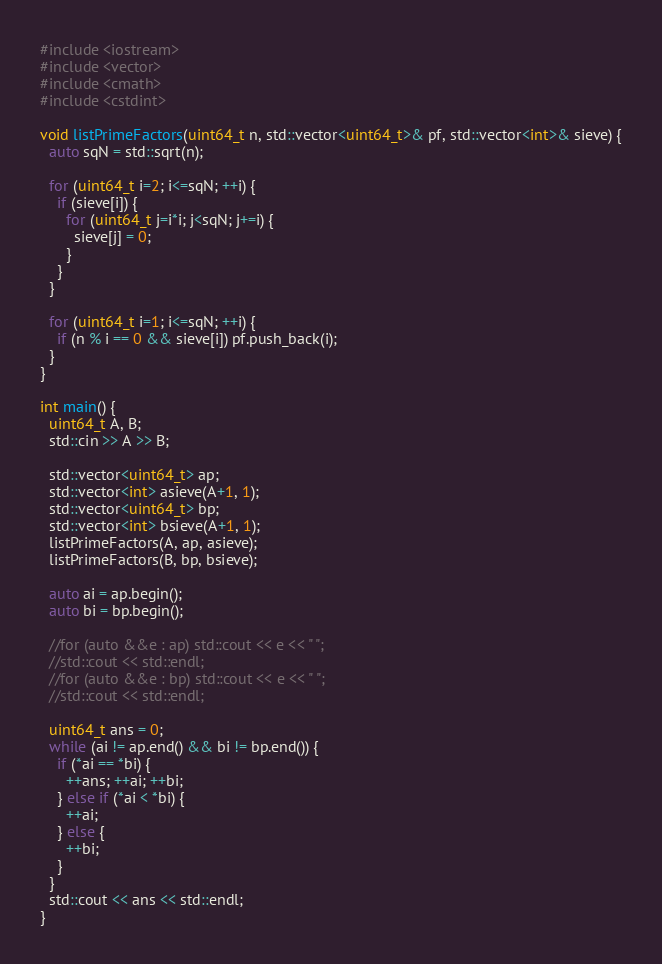Convert code to text. <code><loc_0><loc_0><loc_500><loc_500><_C++_>#include <iostream>
#include <vector>
#include <cmath>
#include <cstdint>

void listPrimeFactors(uint64_t n, std::vector<uint64_t>& pf, std::vector<int>& sieve) {
  auto sqN = std::sqrt(n);
  
  for (uint64_t i=2; i<=sqN; ++i) {
    if (sieve[i]) {
      for (uint64_t j=i*i; j<sqN; j+=i) {
        sieve[j] = 0;
      }
    }
  }
  
  for (uint64_t i=1; i<=sqN; ++i) {
    if (n % i == 0 && sieve[i]) pf.push_back(i);
  }
}

int main() {
  uint64_t A, B;
  std::cin >> A >> B;
  
  std::vector<uint64_t> ap;
  std::vector<int> asieve(A+1, 1);
  std::vector<uint64_t> bp;
  std::vector<int> bsieve(A+1, 1);
  listPrimeFactors(A, ap, asieve);
  listPrimeFactors(B, bp, bsieve);
  
  auto ai = ap.begin();
  auto bi = bp.begin();
  
  //for (auto &&e : ap) std::cout << e << " ";
  //std::cout << std::endl;
  //for (auto &&e : bp) std::cout << e << " ";
  //std::cout << std::endl;
  
  uint64_t ans = 0;
  while (ai != ap.end() && bi != bp.end()) {
    if (*ai == *bi) {
      ++ans; ++ai; ++bi;
    } else if (*ai < *bi) {
      ++ai;
    } else {
      ++bi;
    }
  }
  std::cout << ans << std::endl;
}</code> 